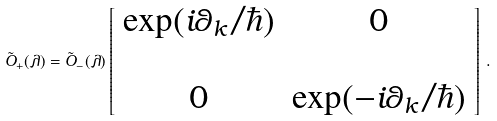<formula> <loc_0><loc_0><loc_500><loc_500>\tilde { O } _ { + } ( \lambda ) = \tilde { O } _ { - } ( \lambda ) \left [ \begin{array} { c c } \exp ( i \theta _ { k } / \hbar { ) } & 0 \\ \\ 0 & \exp ( - i \theta _ { k } / \hbar { ) } \end{array} \right ] \, .</formula> 